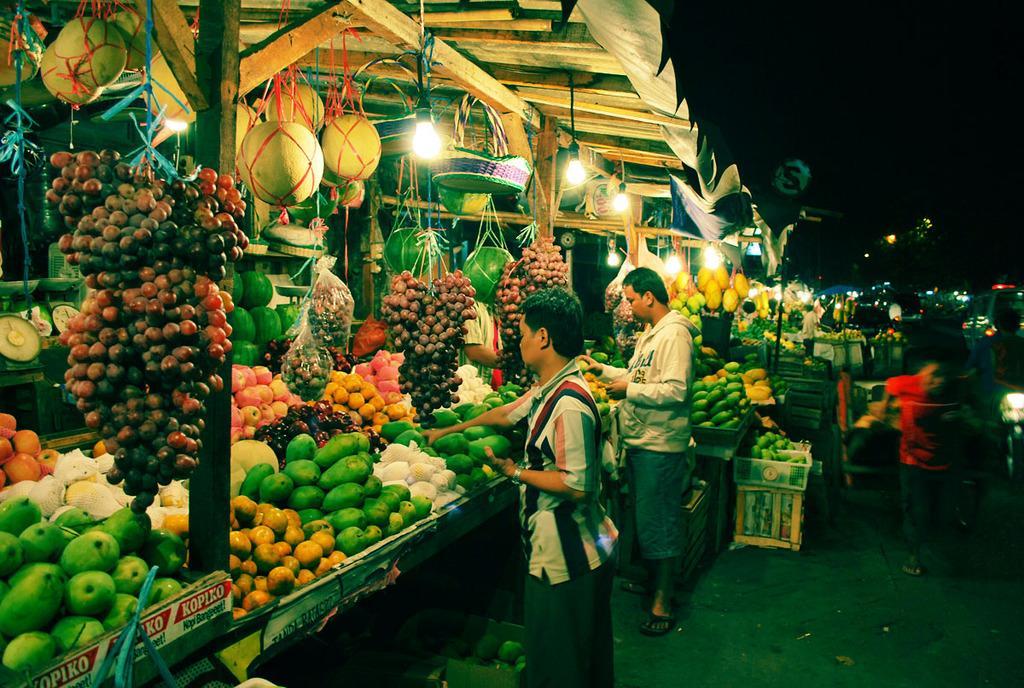Please provide a concise description of this image. In this image I can see a fruit market and different fruits. I can see few people standing and holding fruits. Top I can see few lights and wooden shed. 